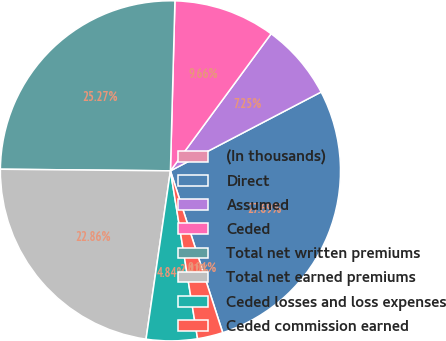Convert chart. <chart><loc_0><loc_0><loc_500><loc_500><pie_chart><fcel>(In thousands)<fcel>Direct<fcel>Assumed<fcel>Ceded<fcel>Total net written premiums<fcel>Total net earned premiums<fcel>Ceded losses and loss expenses<fcel>Ceded commission earned<nl><fcel>0.01%<fcel>27.69%<fcel>7.25%<fcel>9.66%<fcel>25.27%<fcel>22.86%<fcel>4.84%<fcel>2.42%<nl></chart> 